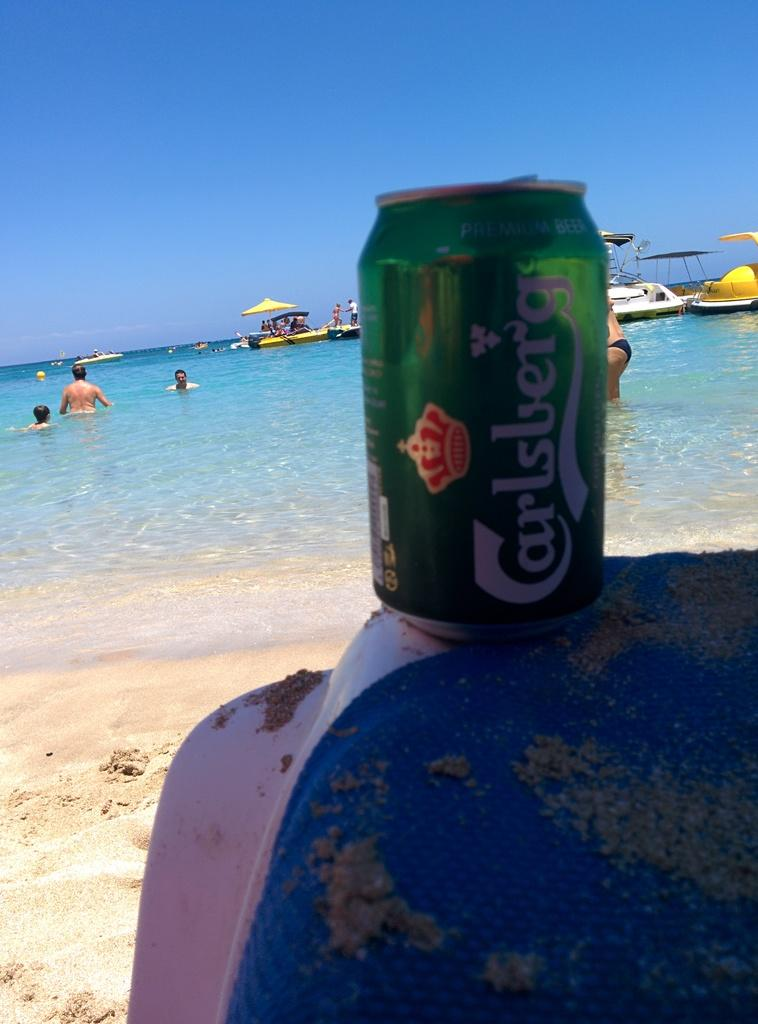Provide a one-sentence caption for the provided image. a can that had the word Carlsberg on it. 